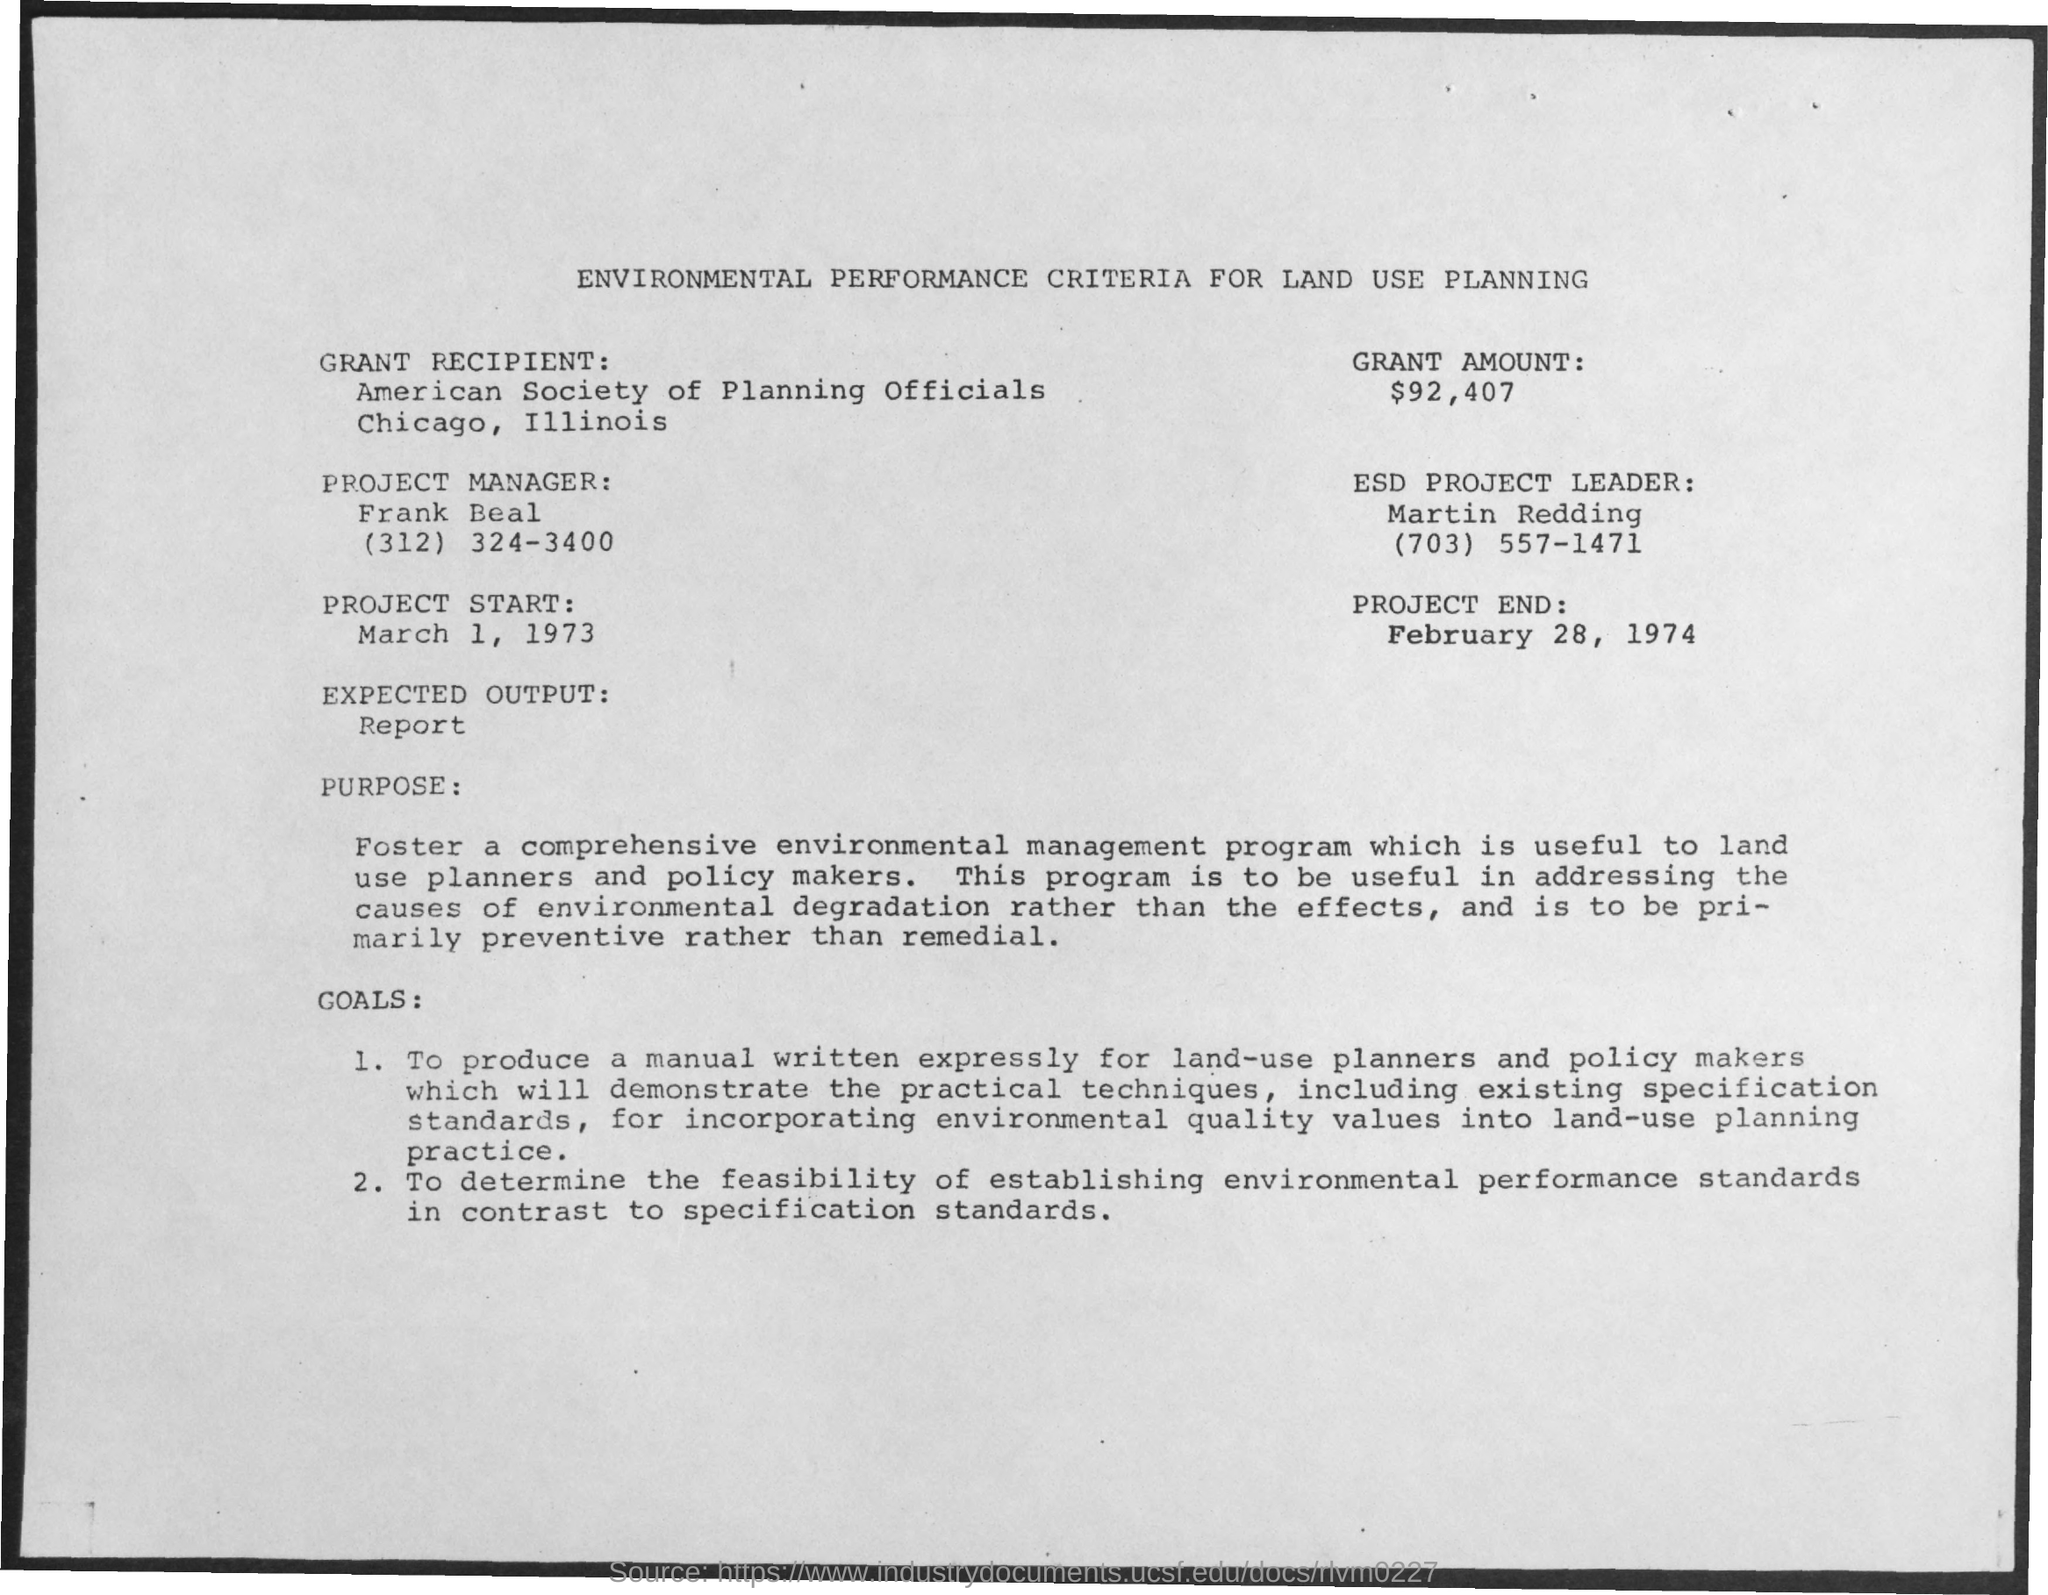What is the Grant Amount mentioned in the document?
Provide a short and direct response. $92,407. Who is the Project Manager as per the document?
Offer a very short reply. Frank Beal. Who is the ESD Project Leader as per the document?
Keep it short and to the point. Martin Redding. What is the Project Start date mentioned in the document?
Ensure brevity in your answer.  March 1, 1973. What is the Project End Date mentioned in the document?
Provide a short and direct response. February 28, 1974. 